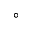Convert formula to latex. <formula><loc_0><loc_0><loc_500><loc_500>^ { \circ }</formula> 